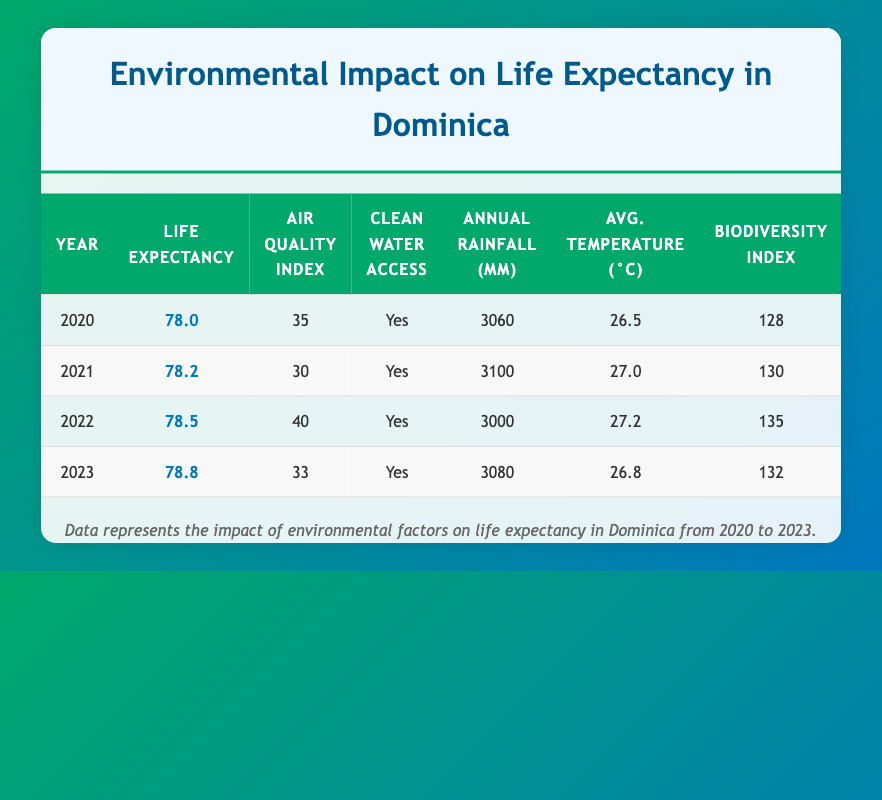What was the average life expectancy in 2021? In the table, under the "Life Expectancy" column for the year 2021, the average life expectancy is listed as 78.2. Therefore, the answer is taken directly from that specific row.
Answer: 78.2 What is the air quality index in 2022? To find this, we look at the row for the year 2022. The air quality index listed in that row is 40. This value is directly referenced from the corresponding column.
Answer: 40 Did Dominica have access to clean water in 2023? Checking the "Clean Water Access" column for the year 2023, it states "Yes." This indicates that the availability of clean water was confirmed for that year.
Answer: Yes Which year had the highest biodiversity index? We examine the "Biodiversity Index" column across all years. The values are 128 for 2020, 130 for 2021, 135 for 2022, and 132 for 2023. The highest value is 135, found in the year 2022, making that the answer.
Answer: 2022 What is the difference in average life expectancy between 2020 and 2023? The average life expectancy for 2020 is 78.0, and for 2023 it is 78.8. We need to calculate the difference: 78.8 - 78.0 = 0.8. Thus, the difference in life expectancy across these two years is 0.8.
Answer: 0.8 What was the average temperature in 2021 compared to 2022? The average temperature in 2021 is 27.0 and in 2022 it is 27.2. To compare, we notice that 27.2 is higher than 27.0 by 0.2 degrees Celsius. This indicates that the average temperature increased from 2021 to 2022.
Answer: 0.2 In which year did the air quality index fall below 35? Looking at the "Air Quality Index," we see values of 35 for 2020, 30 for 2021, 40 for 2022, and 33 for 2023. The only year with an air quality index below 35 is 2021, confirming that it was the only instance within the provided years.
Answer: 2021 What was the total annual rainfall in millimeters for the years 2021 and 2023 combined? We first find the annual rainfall for 2021, which is 3100 mm, and for 2023, which is 3080 mm. Adding these two values together gives us 3100 + 3080 = 6180 mm. This is the total annual rainfall for those two years.
Answer: 6180 Which year showed the lowest annual rainfall? Reviewing the "Annual Rainfall (mm)" column, we see values of 3060 (2020), 3100 (2021), 3000 (2022), and 3080 (2023). The lowest value of 3000 mm appears in the year 2022, making that the answer.
Answer: 2022 